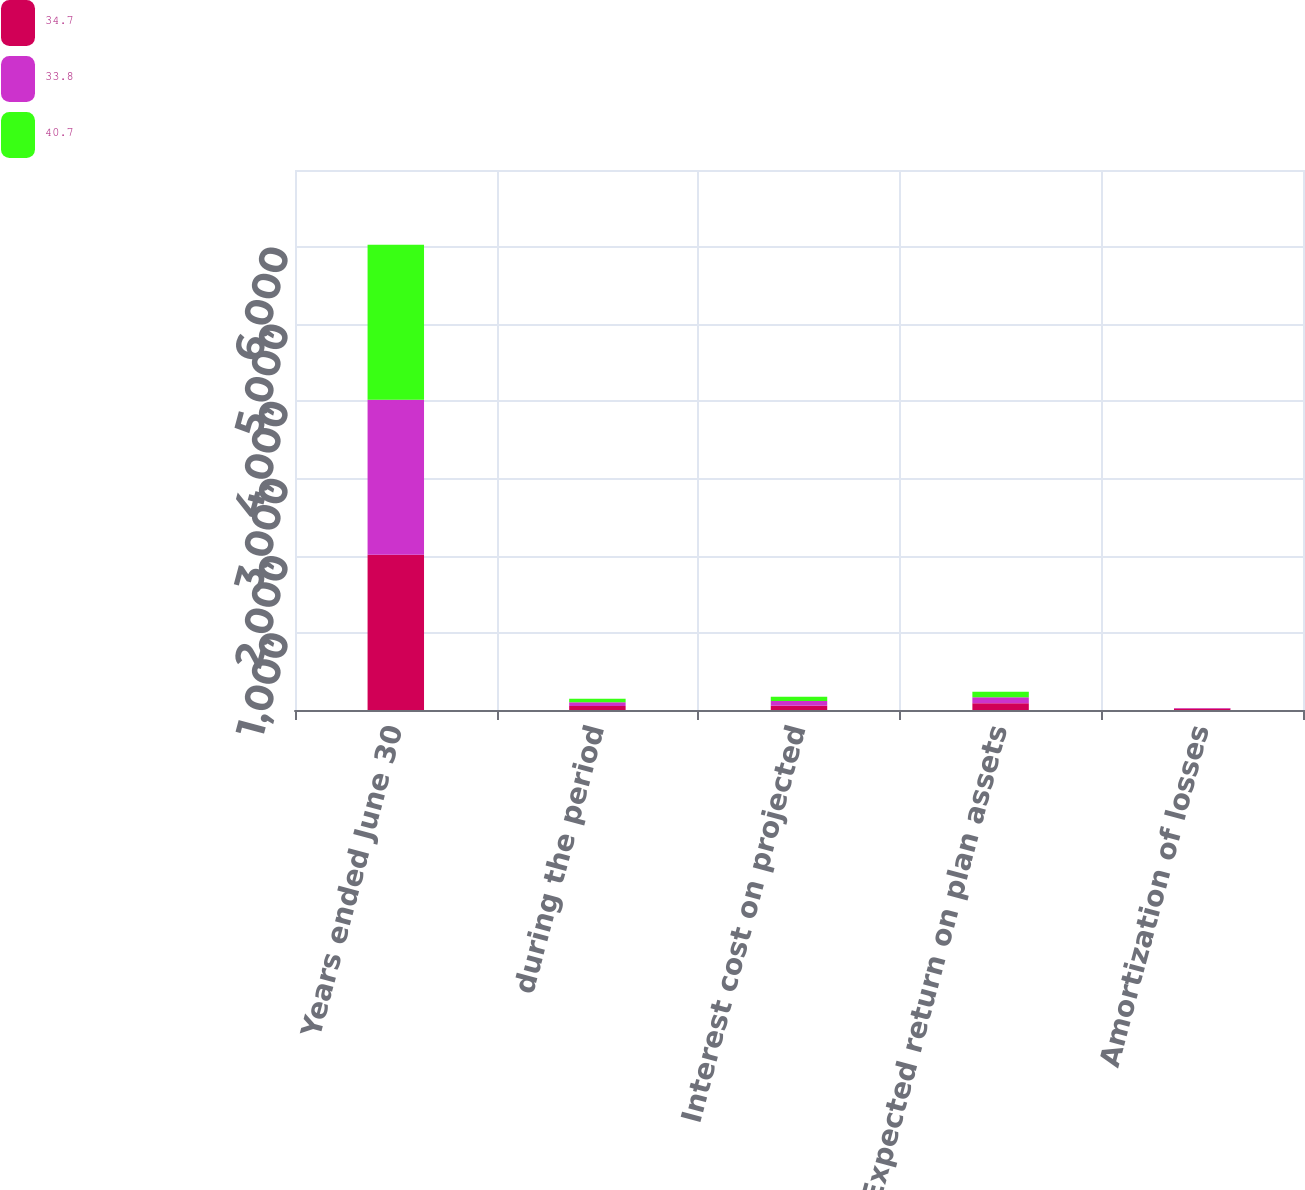Convert chart. <chart><loc_0><loc_0><loc_500><loc_500><stacked_bar_chart><ecel><fcel>Years ended June 30<fcel>during the period<fcel>Interest cost on projected<fcel>Expected return on plan assets<fcel>Amortization of losses<nl><fcel>34.7<fcel>2011<fcel>52.5<fcel>56.6<fcel>88.5<fcel>20.1<nl><fcel>33.8<fcel>2010<fcel>47.6<fcel>59.1<fcel>76.5<fcel>4.5<nl><fcel>40.7<fcel>2009<fcel>46.2<fcel>56.7<fcel>70.3<fcel>1.2<nl></chart> 